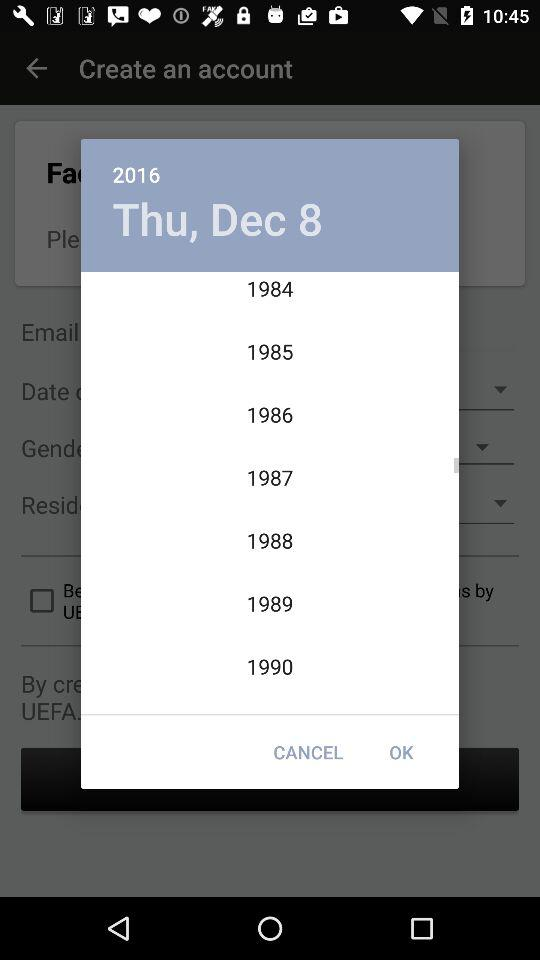What is the selected date? The selected date is Thursday, December 8, 2016. 